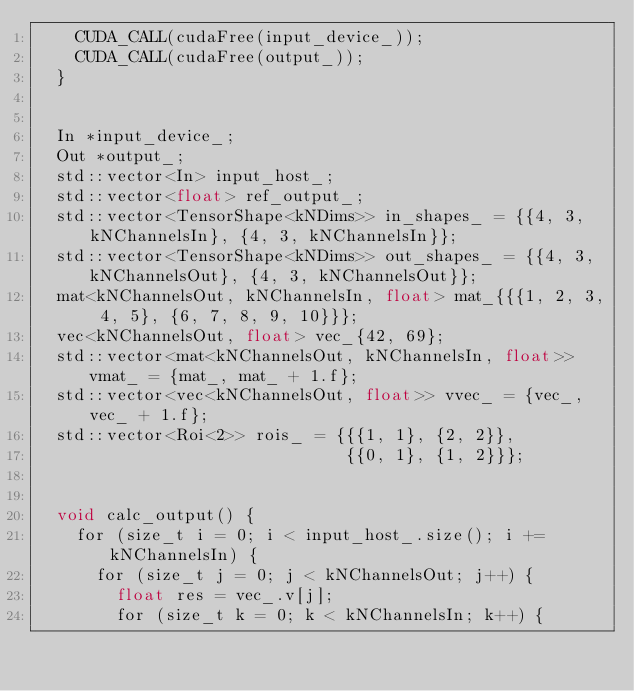<code> <loc_0><loc_0><loc_500><loc_500><_Cuda_>    CUDA_CALL(cudaFree(input_device_));
    CUDA_CALL(cudaFree(output_));
  }


  In *input_device_;
  Out *output_;
  std::vector<In> input_host_;
  std::vector<float> ref_output_;
  std::vector<TensorShape<kNDims>> in_shapes_ = {{4, 3, kNChannelsIn}, {4, 3, kNChannelsIn}};
  std::vector<TensorShape<kNDims>> out_shapes_ = {{4, 3, kNChannelsOut}, {4, 3, kNChannelsOut}};
  mat<kNChannelsOut, kNChannelsIn, float> mat_{{{1, 2, 3, 4, 5}, {6, 7, 8, 9, 10}}};
  vec<kNChannelsOut, float> vec_{42, 69};
  std::vector<mat<kNChannelsOut, kNChannelsIn, float>> vmat_ = {mat_, mat_ + 1.f};
  std::vector<vec<kNChannelsOut, float>> vvec_ = {vec_, vec_ + 1.f};
  std::vector<Roi<2>> rois_ = {{{1, 1}, {2, 2}},
                               {{0, 1}, {1, 2}}};


  void calc_output() {
    for (size_t i = 0; i < input_host_.size(); i += kNChannelsIn) {
      for (size_t j = 0; j < kNChannelsOut; j++) {
        float res = vec_.v[j];
        for (size_t k = 0; k < kNChannelsIn; k++) {</code> 